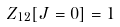<formula> <loc_0><loc_0><loc_500><loc_500>Z _ { 1 2 } [ J = 0 ] = 1</formula> 